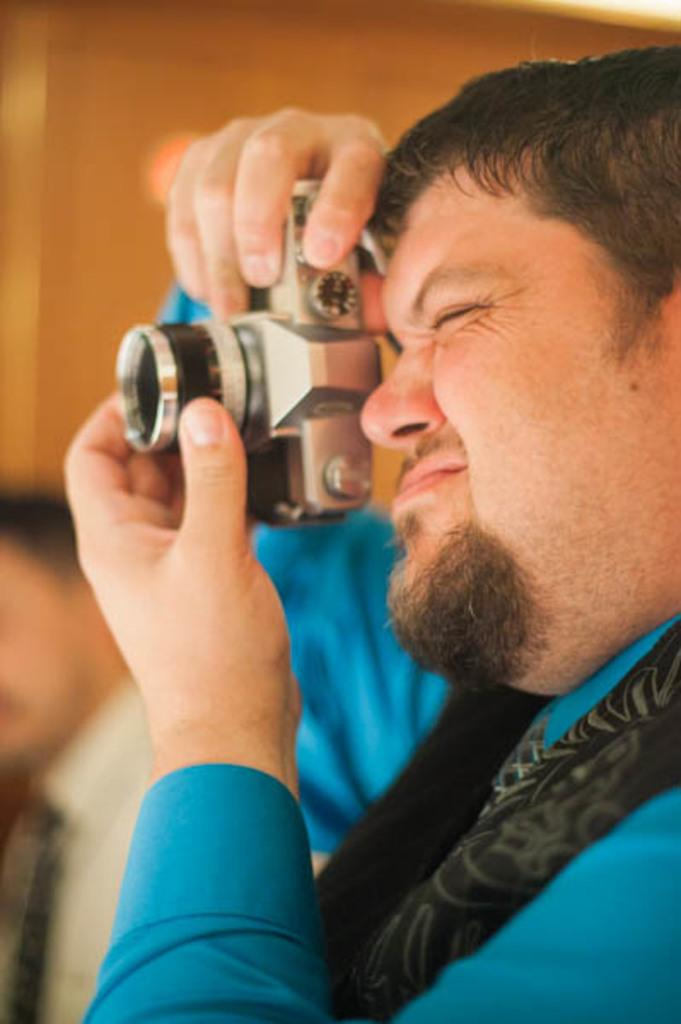What type of setting is depicted in the image? The image is of an indoor setting. Who is the main subject in the image? There is a man in the center of the image. What is the man holding in the image? The man is holding a camera. What is the man doing with the camera? The man appears to be taking pictures. What can be seen in the background of the image? There is a wall visible in the background of the image. What is the man's opinion on the destruction of chairs in the image? There is no mention of chairs or destruction in the image, so it is not possible to determine the man's opinion on the matter. 